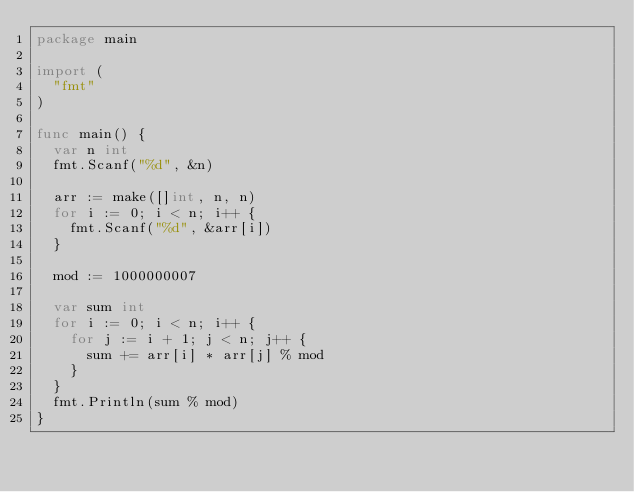<code> <loc_0><loc_0><loc_500><loc_500><_Go_>package main

import (
	"fmt"
)

func main() {
	var n int
	fmt.Scanf("%d", &n)

	arr := make([]int, n, n)
	for i := 0; i < n; i++ {
		fmt.Scanf("%d", &arr[i])
	}

	mod := 1000000007

	var sum int
	for i := 0; i < n; i++ {
		for j := i + 1; j < n; j++ {
			sum += arr[i] * arr[j] % mod
		}
	}
	fmt.Println(sum % mod)
}
</code> 